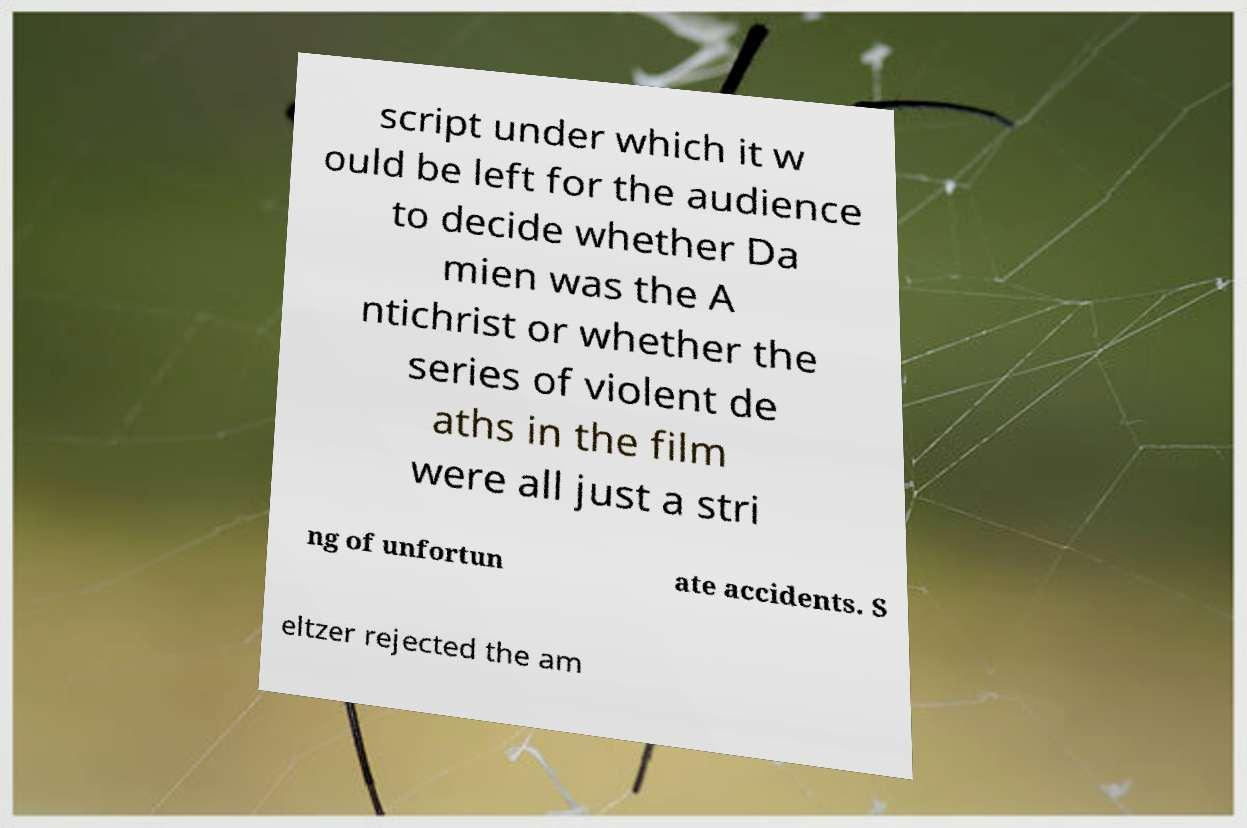For documentation purposes, I need the text within this image transcribed. Could you provide that? script under which it w ould be left for the audience to decide whether Da mien was the A ntichrist or whether the series of violent de aths in the film were all just a stri ng of unfortun ate accidents. S eltzer rejected the am 